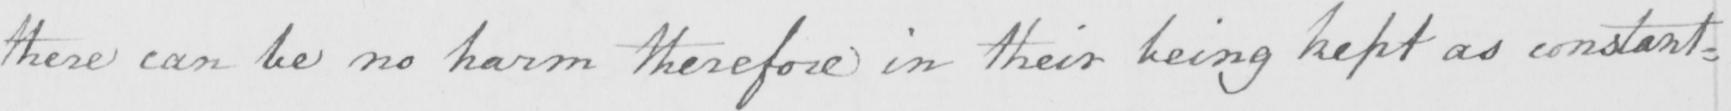What does this handwritten line say? there can be no harm therefore in their being kept as constant= 